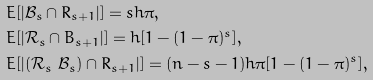<formula> <loc_0><loc_0><loc_500><loc_500>& E [ | \mathcal { B } _ { s } \cap R _ { s + 1 } | ] = s h \pi , \\ & E [ | \mathcal { R } _ { s } \cap B _ { s + 1 } | ] = h [ 1 - ( 1 - \pi ) ^ { s } ] , \\ & E [ | ( \mathcal { R } _ { s } \ \mathcal { B } _ { s } ) \cap R _ { s + 1 } | ] = ( n - s - 1 ) h \pi [ 1 - ( 1 - \pi ) ^ { s } ] ,</formula> 